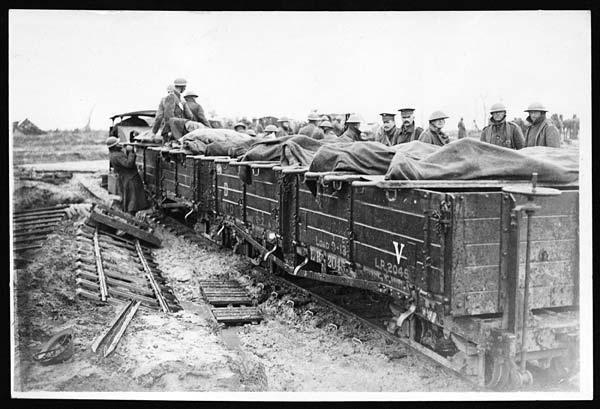How many umbrellas are there?
Give a very brief answer. 0. How many people can you see?
Give a very brief answer. 1. 